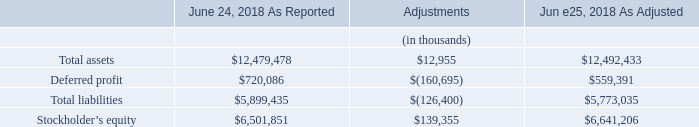Note 3: Recent Accounting Pronouncements
Recently Adopted
In May 2014, the FASB released ASU 2014-09, “Revenue from Contracts with Customers,” to supersede nearly all existing revenue recognition guidance under GAAP. The FASB issued subsequent amendments to the initial guidance in August 2015, March 2016, April 2016, May 2016 and December 2016 within ASU 2015–14, ASU 2016–08, ASU 2016–10, ASU 2016–12 and ASU 2016–20, respectively; all of which in combination with ASU 2014-09 were codified as Accounting Standard Codification Topic 606 (“ASC 606”). The core principle of the standard is to recognize revenues when promised goods or services are transferred to customers in an amount that reflects the consideration that is expected to be received for those goods or services. The Company adopted ASC 606 on the first day of the current fiscal year, June 25, 2018, under the modified retrospective approach, applying the amendments to prospective reporting periods. Results for reporting periods beginning on or after June 25, 2018 are presented under ASC 606, while prior period amounts are not adjusted and continue to be reported in accordance with the historic accounting under ASC 605. In connection with the adoption of ASC 606, the Company’s revenue recognition policy has been amended, refer to Note 2—Summary of Significant Accounting Policies for a description of the policy.
The cumulative effect of the changes made to the Company’s Consolidated Balance Sheet as of June 25, 2018 for the adoption of ASC 606 to all contracts with customers that were not completed as of June 24, 2018 was recorded as an adjustment to retained earnings as of the adoption date as follows:
What is the stockholder's equity as reported in June 24, 2018?
Answer scale should be: thousand. $6,501,851. What is the total liabilities as reported in June 24, 2018?
Answer scale should be: thousand. $5,899,435. What is the deferred profit as reported in June 24, 2018?
Answer scale should be: thousand. $720,086. What is the percentage change in the total assets after the adjustment?
Answer scale should be: percent. (12,492,433-12,479,478)/12,479,478
Answer: 0.1. What is the percentage change in the deferred profit after the adjustment?
Answer scale should be: percent. (559,391-720,086)/720,086
Answer: -22.32. What is the percentage change in the total liabilities after the adjustment?
Answer scale should be: percent. (5,773,035-5,899,435)/5,899,435
Answer: -2.14. 